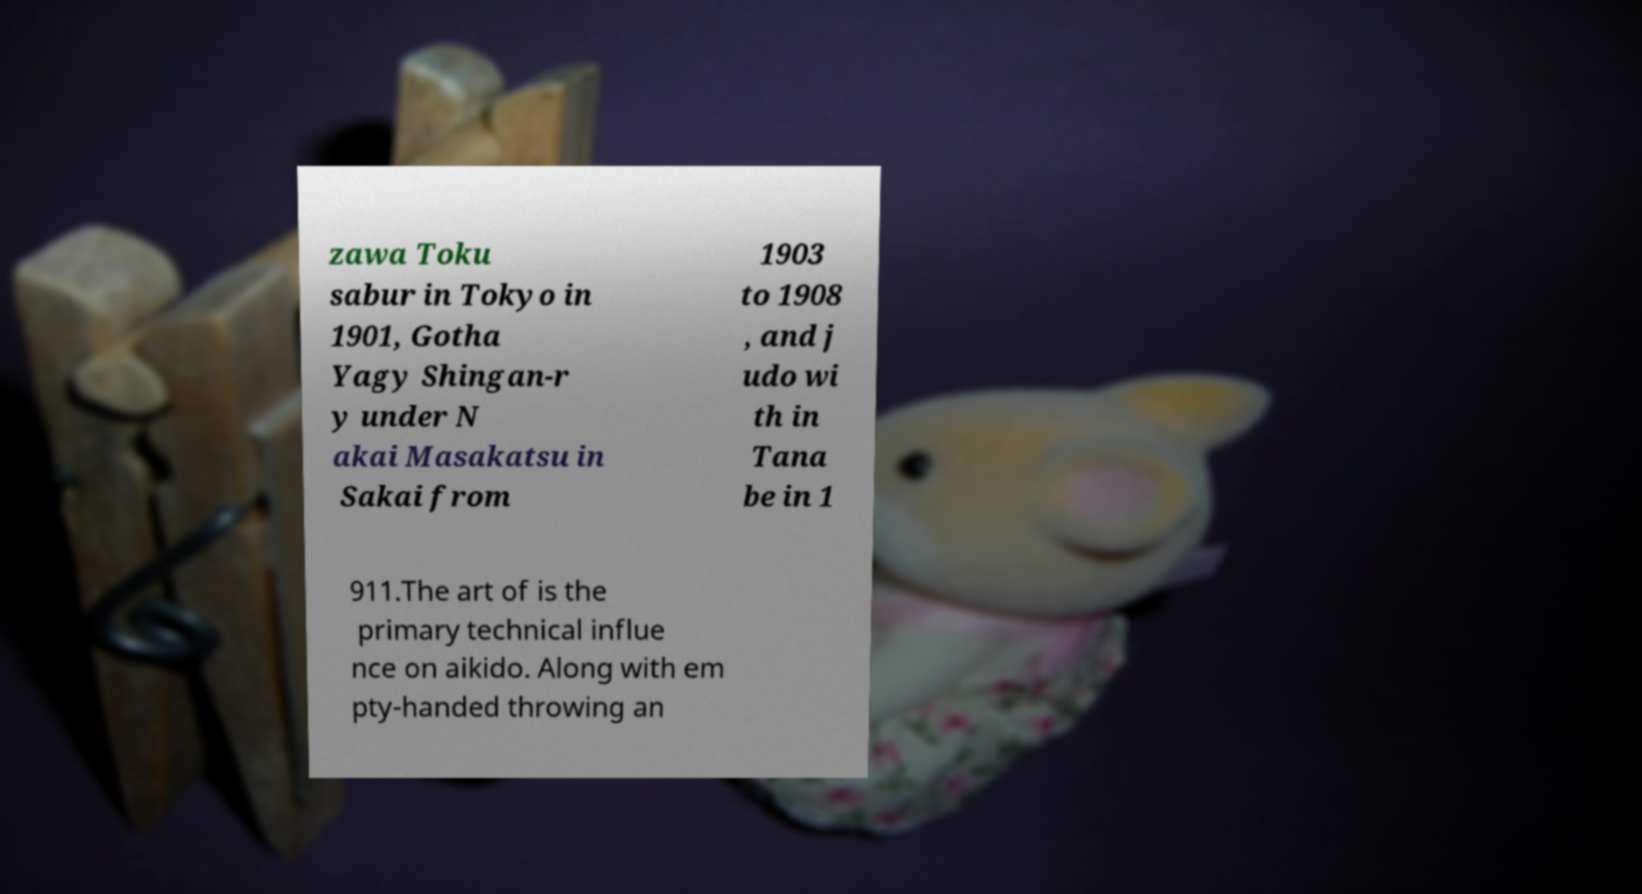There's text embedded in this image that I need extracted. Can you transcribe it verbatim? zawa Toku sabur in Tokyo in 1901, Gotha Yagy Shingan-r y under N akai Masakatsu in Sakai from 1903 to 1908 , and j udo wi th in Tana be in 1 911.The art of is the primary technical influe nce on aikido. Along with em pty-handed throwing an 